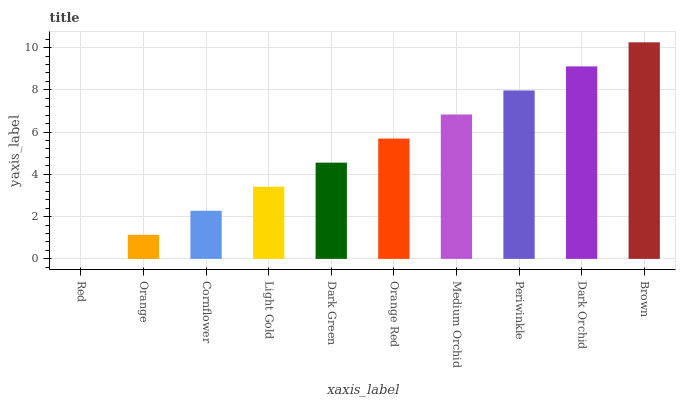Is Red the minimum?
Answer yes or no. Yes. Is Brown the maximum?
Answer yes or no. Yes. Is Orange the minimum?
Answer yes or no. No. Is Orange the maximum?
Answer yes or no. No. Is Orange greater than Red?
Answer yes or no. Yes. Is Red less than Orange?
Answer yes or no. Yes. Is Red greater than Orange?
Answer yes or no. No. Is Orange less than Red?
Answer yes or no. No. Is Orange Red the high median?
Answer yes or no. Yes. Is Dark Green the low median?
Answer yes or no. Yes. Is Brown the high median?
Answer yes or no. No. Is Brown the low median?
Answer yes or no. No. 